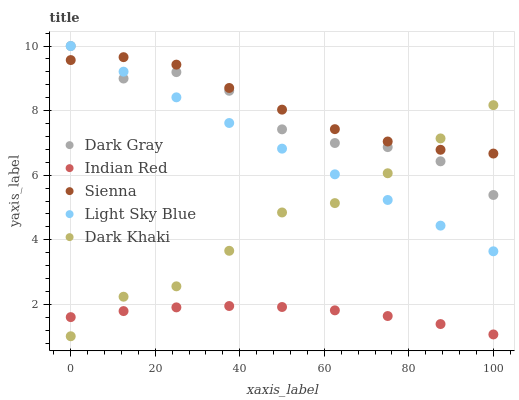Does Indian Red have the minimum area under the curve?
Answer yes or no. Yes. Does Sienna have the maximum area under the curve?
Answer yes or no. Yes. Does Light Sky Blue have the minimum area under the curve?
Answer yes or no. No. Does Light Sky Blue have the maximum area under the curve?
Answer yes or no. No. Is Light Sky Blue the smoothest?
Answer yes or no. Yes. Is Dark Gray the roughest?
Answer yes or no. Yes. Is Sienna the smoothest?
Answer yes or no. No. Is Sienna the roughest?
Answer yes or no. No. Does Dark Khaki have the lowest value?
Answer yes or no. Yes. Does Light Sky Blue have the lowest value?
Answer yes or no. No. Does Light Sky Blue have the highest value?
Answer yes or no. Yes. Does Sienna have the highest value?
Answer yes or no. No. Is Indian Red less than Dark Gray?
Answer yes or no. Yes. Is Sienna greater than Indian Red?
Answer yes or no. Yes. Does Dark Khaki intersect Light Sky Blue?
Answer yes or no. Yes. Is Dark Khaki less than Light Sky Blue?
Answer yes or no. No. Is Dark Khaki greater than Light Sky Blue?
Answer yes or no. No. Does Indian Red intersect Dark Gray?
Answer yes or no. No. 